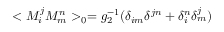Convert formula to latex. <formula><loc_0><loc_0><loc_500><loc_500>< M _ { i } ^ { j } M _ { m } ^ { n } > _ { 0 } = g _ { 2 } ^ { - 1 } ( \delta _ { i m } \delta ^ { j n } + \delta _ { i } ^ { n } \delta _ { m } ^ { j } )</formula> 